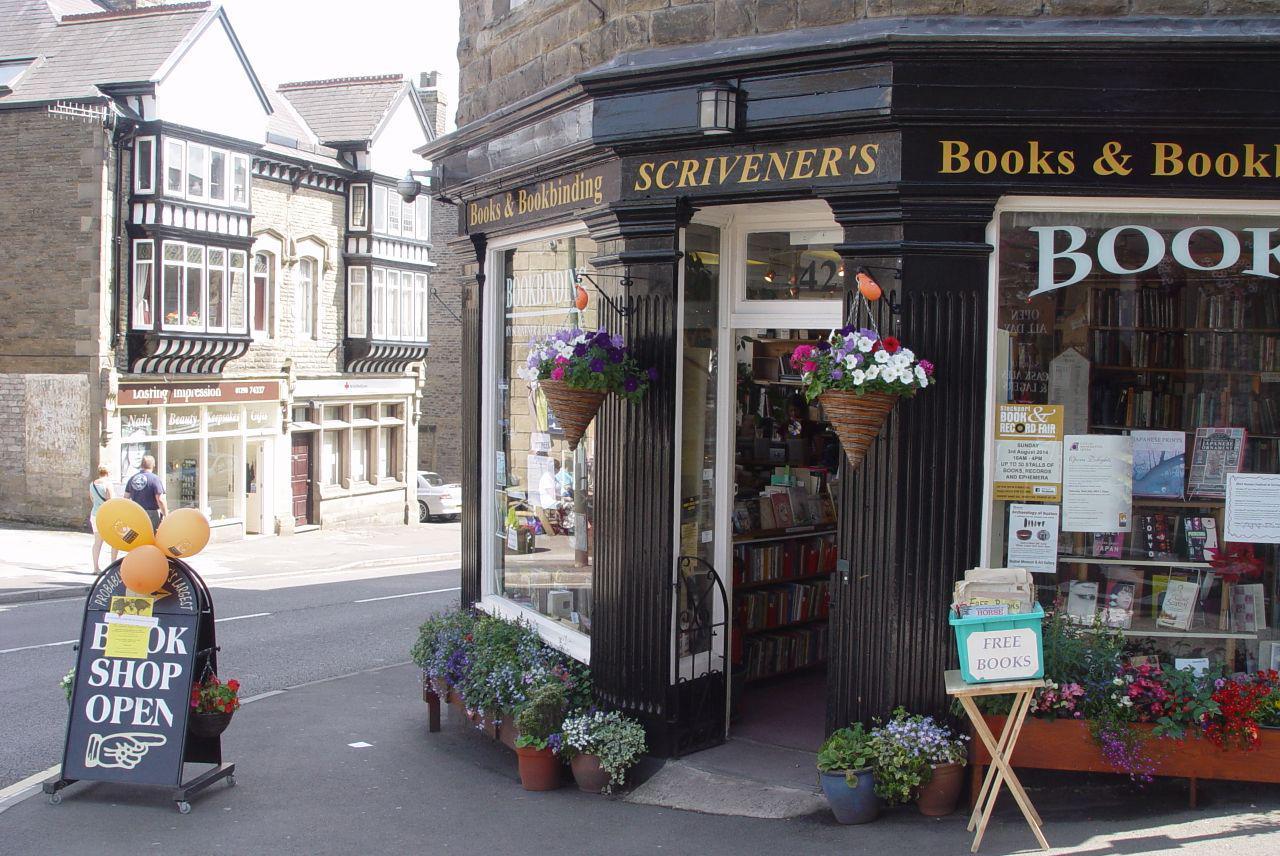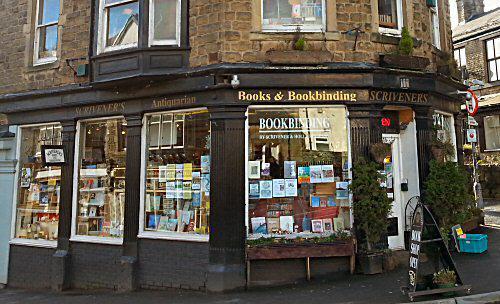The first image is the image on the left, the second image is the image on the right. Examine the images to the left and right. Is the description "Both images feature the exterior of a bookshop." accurate? Answer yes or no. Yes. The first image is the image on the left, the second image is the image on the right. Considering the images on both sides, is "To the left of the build there is at least one folding sign advertising the shop." valid? Answer yes or no. Yes. 